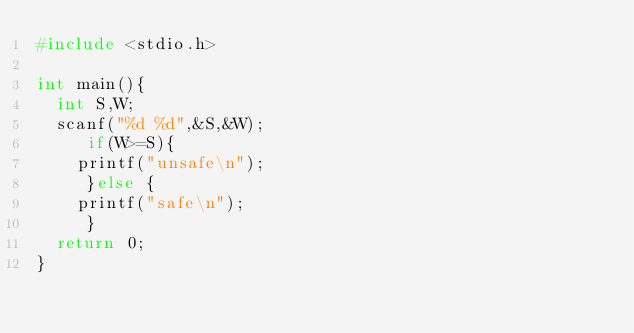Convert code to text. <code><loc_0><loc_0><loc_500><loc_500><_C_>#include <stdio.h>

int main(){
  int S,W;
  scanf("%d %d",&S,&W);
     if(W>=S){
    printf("unsafe\n");
     }else {
    printf("safe\n");
     }
  return 0;
}</code> 